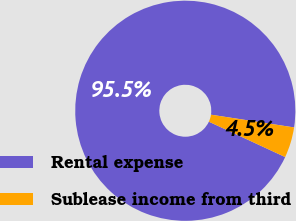Convert chart to OTSL. <chart><loc_0><loc_0><loc_500><loc_500><pie_chart><fcel>Rental expense<fcel>Sublease income from third<nl><fcel>95.51%<fcel>4.49%<nl></chart> 